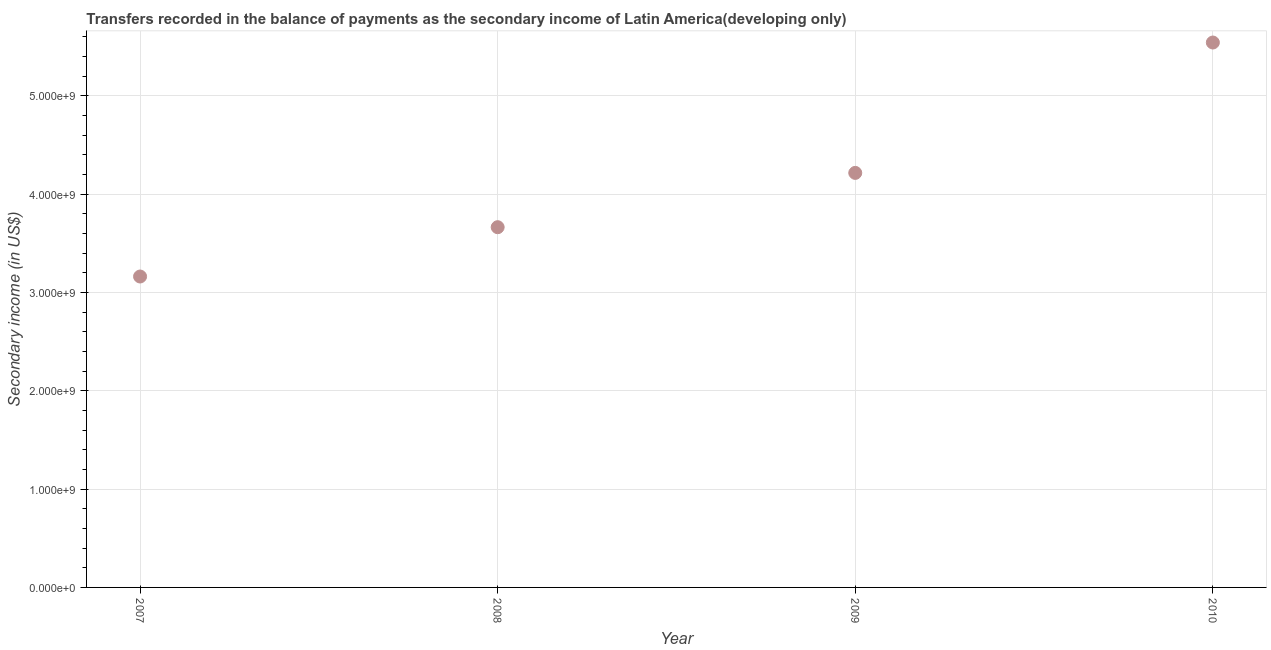What is the amount of secondary income in 2008?
Provide a succinct answer. 3.66e+09. Across all years, what is the maximum amount of secondary income?
Your response must be concise. 5.54e+09. Across all years, what is the minimum amount of secondary income?
Ensure brevity in your answer.  3.16e+09. What is the sum of the amount of secondary income?
Your answer should be compact. 1.66e+1. What is the difference between the amount of secondary income in 2008 and 2010?
Keep it short and to the point. -1.88e+09. What is the average amount of secondary income per year?
Keep it short and to the point. 4.15e+09. What is the median amount of secondary income?
Your answer should be compact. 3.94e+09. In how many years, is the amount of secondary income greater than 2000000000 US$?
Provide a succinct answer. 4. What is the ratio of the amount of secondary income in 2009 to that in 2010?
Ensure brevity in your answer.  0.76. Is the amount of secondary income in 2007 less than that in 2008?
Ensure brevity in your answer.  Yes. What is the difference between the highest and the second highest amount of secondary income?
Provide a succinct answer. 1.33e+09. What is the difference between the highest and the lowest amount of secondary income?
Offer a terse response. 2.38e+09. Does the amount of secondary income monotonically increase over the years?
Make the answer very short. Yes. How many dotlines are there?
Your answer should be very brief. 1. How many years are there in the graph?
Ensure brevity in your answer.  4. Are the values on the major ticks of Y-axis written in scientific E-notation?
Offer a terse response. Yes. Does the graph contain grids?
Make the answer very short. Yes. What is the title of the graph?
Your answer should be very brief. Transfers recorded in the balance of payments as the secondary income of Latin America(developing only). What is the label or title of the X-axis?
Offer a terse response. Year. What is the label or title of the Y-axis?
Give a very brief answer. Secondary income (in US$). What is the Secondary income (in US$) in 2007?
Provide a short and direct response. 3.16e+09. What is the Secondary income (in US$) in 2008?
Provide a succinct answer. 3.66e+09. What is the Secondary income (in US$) in 2009?
Offer a very short reply. 4.22e+09. What is the Secondary income (in US$) in 2010?
Provide a succinct answer. 5.54e+09. What is the difference between the Secondary income (in US$) in 2007 and 2008?
Ensure brevity in your answer.  -5.02e+08. What is the difference between the Secondary income (in US$) in 2007 and 2009?
Your answer should be very brief. -1.05e+09. What is the difference between the Secondary income (in US$) in 2007 and 2010?
Provide a succinct answer. -2.38e+09. What is the difference between the Secondary income (in US$) in 2008 and 2009?
Provide a short and direct response. -5.52e+08. What is the difference between the Secondary income (in US$) in 2008 and 2010?
Provide a short and direct response. -1.88e+09. What is the difference between the Secondary income (in US$) in 2009 and 2010?
Provide a succinct answer. -1.33e+09. What is the ratio of the Secondary income (in US$) in 2007 to that in 2008?
Keep it short and to the point. 0.86. What is the ratio of the Secondary income (in US$) in 2007 to that in 2009?
Provide a succinct answer. 0.75. What is the ratio of the Secondary income (in US$) in 2007 to that in 2010?
Provide a short and direct response. 0.57. What is the ratio of the Secondary income (in US$) in 2008 to that in 2009?
Offer a very short reply. 0.87. What is the ratio of the Secondary income (in US$) in 2008 to that in 2010?
Offer a terse response. 0.66. What is the ratio of the Secondary income (in US$) in 2009 to that in 2010?
Give a very brief answer. 0.76. 